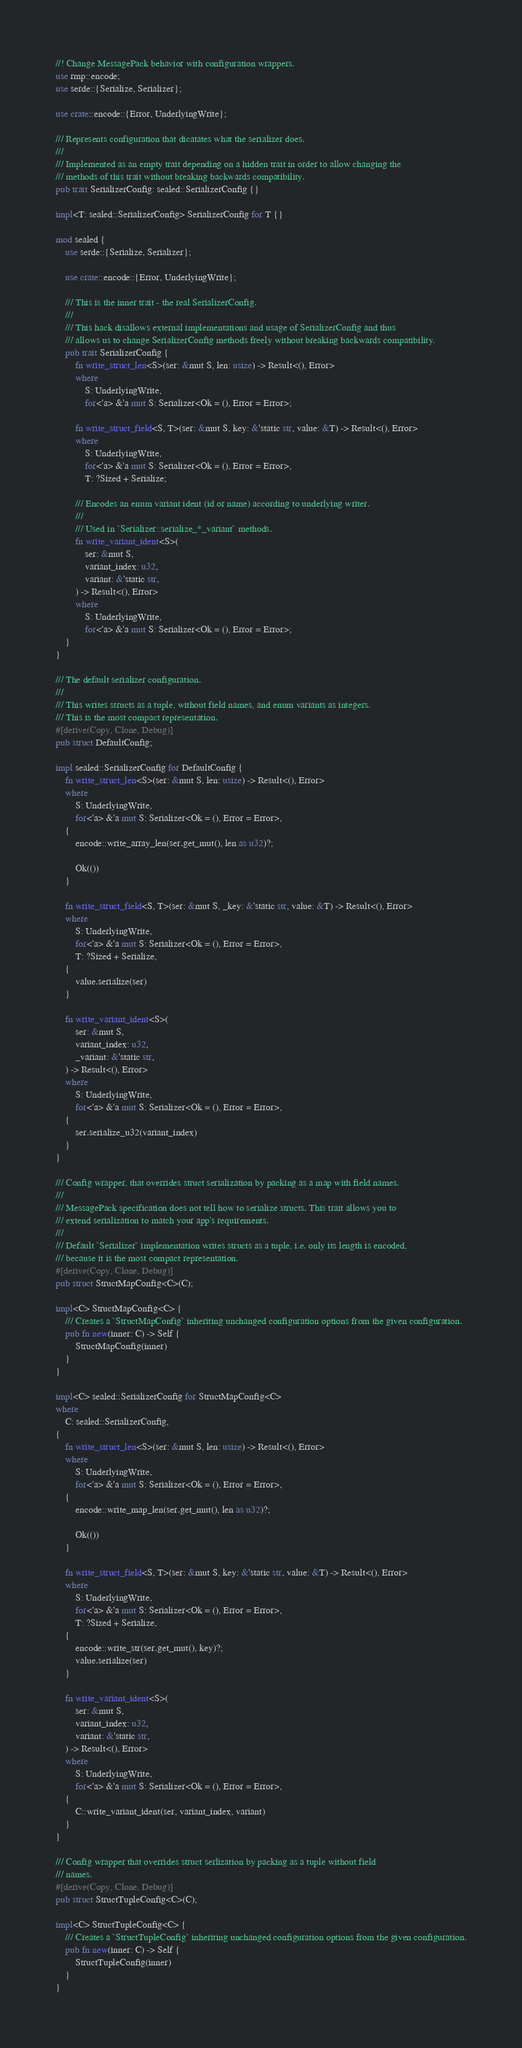Convert code to text. <code><loc_0><loc_0><loc_500><loc_500><_Rust_>//! Change MessagePack behavior with configuration wrappers.
use rmp::encode;
use serde::{Serialize, Serializer};

use crate::encode::{Error, UnderlyingWrite};

/// Represents configuration that dicatates what the serializer does.
///
/// Implemented as an empty trait depending on a hidden trait in order to allow changing the
/// methods of this trait without breaking backwards compatibility.
pub trait SerializerConfig: sealed::SerializerConfig {}

impl<T: sealed::SerializerConfig> SerializerConfig for T {}

mod sealed {
    use serde::{Serialize, Serializer};

    use crate::encode::{Error, UnderlyingWrite};

    /// This is the inner trait - the real SerializerConfig.
    ///
    /// This hack disallows external implementations and usage of SerializerConfig and thus
    /// allows us to change SerializerConfig methods freely without breaking backwards compatibility.
    pub trait SerializerConfig {
        fn write_struct_len<S>(ser: &mut S, len: usize) -> Result<(), Error>
        where
            S: UnderlyingWrite,
            for<'a> &'a mut S: Serializer<Ok = (), Error = Error>;

        fn write_struct_field<S, T>(ser: &mut S, key: &'static str, value: &T) -> Result<(), Error>
        where
            S: UnderlyingWrite,
            for<'a> &'a mut S: Serializer<Ok = (), Error = Error>,
            T: ?Sized + Serialize;

        /// Encodes an enum variant ident (id or name) according to underlying writer.
        ///
        /// Used in `Serializer::serialize_*_variant` methods.
        fn write_variant_ident<S>(
            ser: &mut S,
            variant_index: u32,
            variant: &'static str,
        ) -> Result<(), Error>
        where
            S: UnderlyingWrite,
            for<'a> &'a mut S: Serializer<Ok = (), Error = Error>;
    }
}

/// The default serializer configuration.
///
/// This writes structs as a tuple, without field names, and enum variants as integers.
/// This is the most compact representation.
#[derive(Copy, Clone, Debug)]
pub struct DefaultConfig;

impl sealed::SerializerConfig for DefaultConfig {
    fn write_struct_len<S>(ser: &mut S, len: usize) -> Result<(), Error>
    where
        S: UnderlyingWrite,
        for<'a> &'a mut S: Serializer<Ok = (), Error = Error>,
    {
        encode::write_array_len(ser.get_mut(), len as u32)?;

        Ok(())
    }

    fn write_struct_field<S, T>(ser: &mut S, _key: &'static str, value: &T) -> Result<(), Error>
    where
        S: UnderlyingWrite,
        for<'a> &'a mut S: Serializer<Ok = (), Error = Error>,
        T: ?Sized + Serialize,
    {
        value.serialize(ser)
    }

    fn write_variant_ident<S>(
        ser: &mut S,
        variant_index: u32,
        _variant: &'static str,
    ) -> Result<(), Error>
    where
        S: UnderlyingWrite,
        for<'a> &'a mut S: Serializer<Ok = (), Error = Error>,
    {
        ser.serialize_u32(variant_index)
    }
}

/// Config wrapper, that overrides struct serialization by packing as a map with field names.
///
/// MessagePack specification does not tell how to serialize structs. This trait allows you to
/// extend serialization to match your app's requirements.
///
/// Default `Serializer` implementation writes structs as a tuple, i.e. only its length is encoded,
/// because it is the most compact representation.
#[derive(Copy, Clone, Debug)]
pub struct StructMapConfig<C>(C);

impl<C> StructMapConfig<C> {
    /// Creates a `StructMapConfig` inheriting unchanged configuration options from the given configuration.
    pub fn new(inner: C) -> Self {
        StructMapConfig(inner)
    }
}

impl<C> sealed::SerializerConfig for StructMapConfig<C>
where
    C: sealed::SerializerConfig,
{
    fn write_struct_len<S>(ser: &mut S, len: usize) -> Result<(), Error>
    where
        S: UnderlyingWrite,
        for<'a> &'a mut S: Serializer<Ok = (), Error = Error>,
    {
        encode::write_map_len(ser.get_mut(), len as u32)?;

        Ok(())
    }

    fn write_struct_field<S, T>(ser: &mut S, key: &'static str, value: &T) -> Result<(), Error>
    where
        S: UnderlyingWrite,
        for<'a> &'a mut S: Serializer<Ok = (), Error = Error>,
        T: ?Sized + Serialize,
    {
        encode::write_str(ser.get_mut(), key)?;
        value.serialize(ser)
    }

    fn write_variant_ident<S>(
        ser: &mut S,
        variant_index: u32,
        variant: &'static str,
    ) -> Result<(), Error>
    where
        S: UnderlyingWrite,
        for<'a> &'a mut S: Serializer<Ok = (), Error = Error>,
    {
        C::write_variant_ident(ser, variant_index, variant)
    }
}

/// Config wrapper that overrides struct serlization by packing as a tuple without field
/// names.
#[derive(Copy, Clone, Debug)]
pub struct StructTupleConfig<C>(C);

impl<C> StructTupleConfig<C> {
    /// Creates a `StructTupleConfig` inheriting unchanged configuration options from the given configuration.
    pub fn new(inner: C) -> Self {
        StructTupleConfig(inner)
    }
}
</code> 